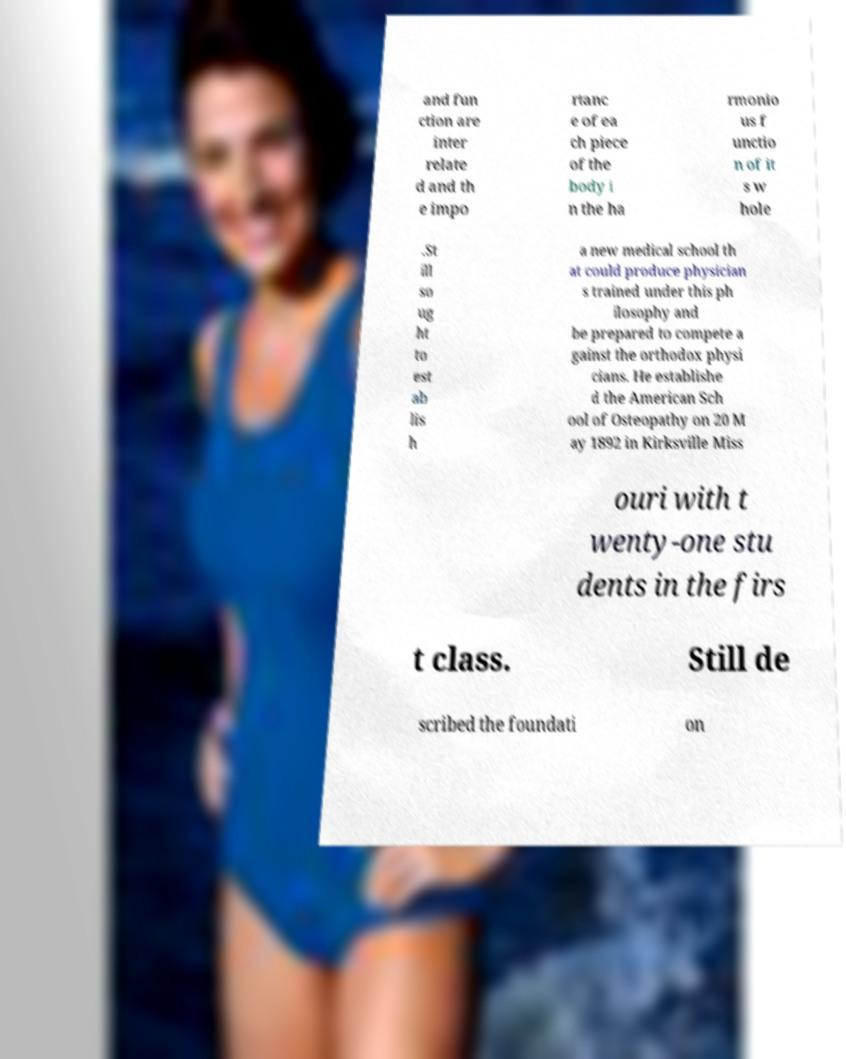For documentation purposes, I need the text within this image transcribed. Could you provide that? and fun ction are inter relate d and th e impo rtanc e of ea ch piece of the body i n the ha rmonio us f unctio n of it s w hole .St ill so ug ht to est ab lis h a new medical school th at could produce physician s trained under this ph ilosophy and be prepared to compete a gainst the orthodox physi cians. He establishe d the American Sch ool of Osteopathy on 20 M ay 1892 in Kirksville Miss ouri with t wenty-one stu dents in the firs t class. Still de scribed the foundati on 